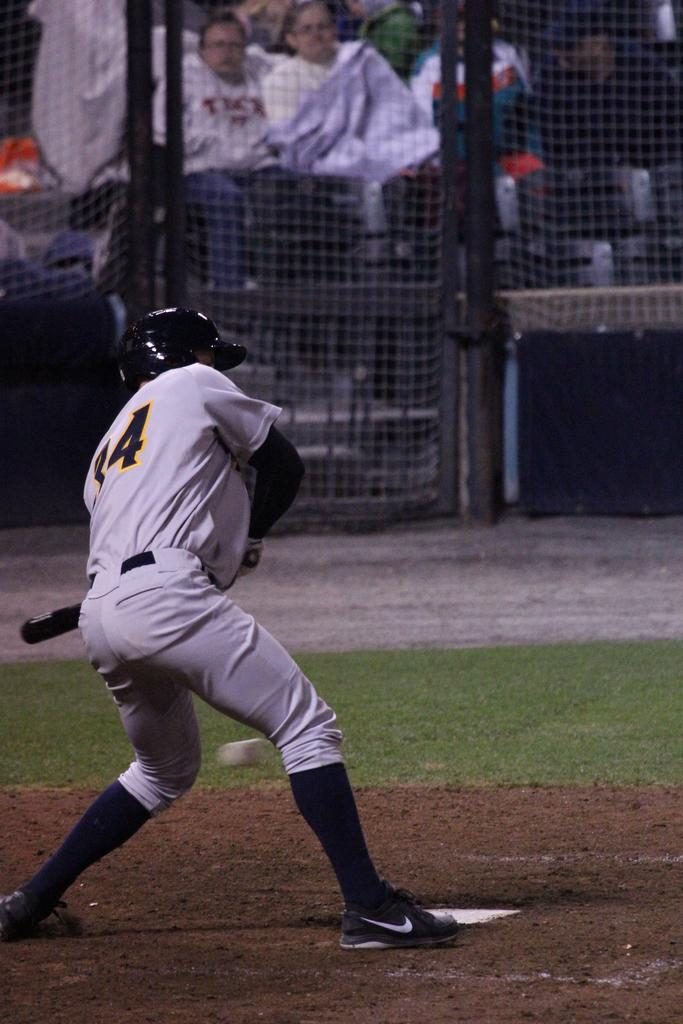What is the person in the image holding? The person is holding a bat in the image. What is the person's position in relation to the ground? The person is standing on the ground. What can be seen in the background of the image? There is fencing visible in the background of the image, and there are other persons present as well. What type of education is the person receiving while holding the bat in the image? There is no indication of education in the image; the person is simply holding a bat. 